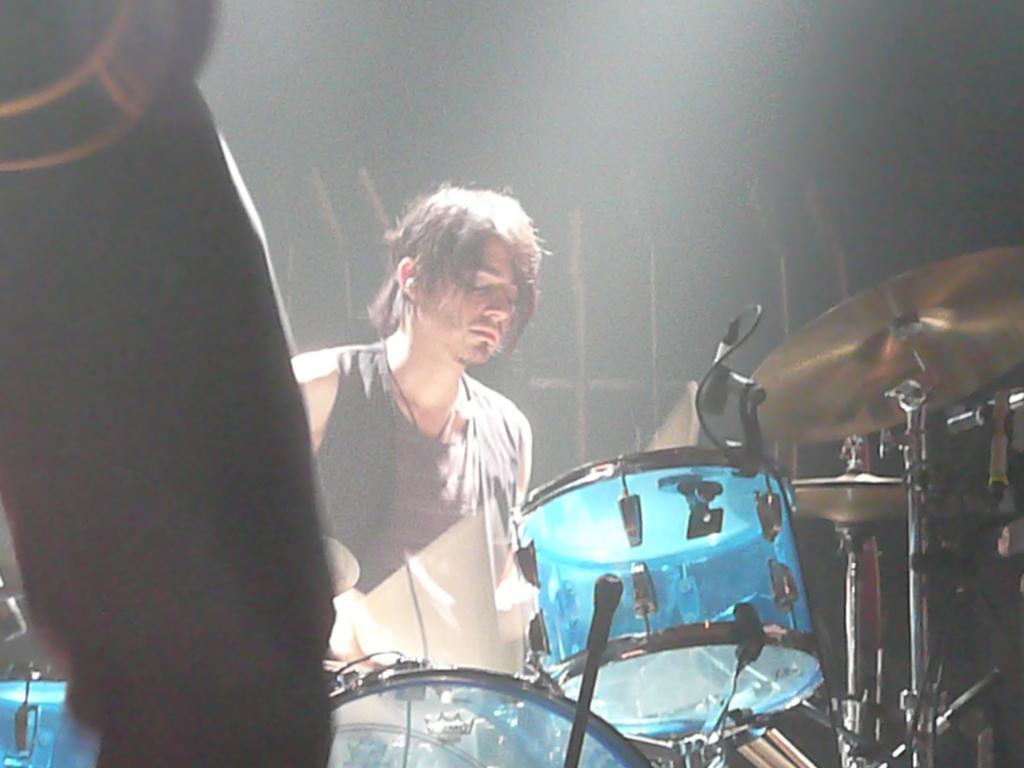In one or two sentences, can you explain what this image depicts? There is one person playing drums in the middle of this image and there is one person's leg on the left side of this image. 